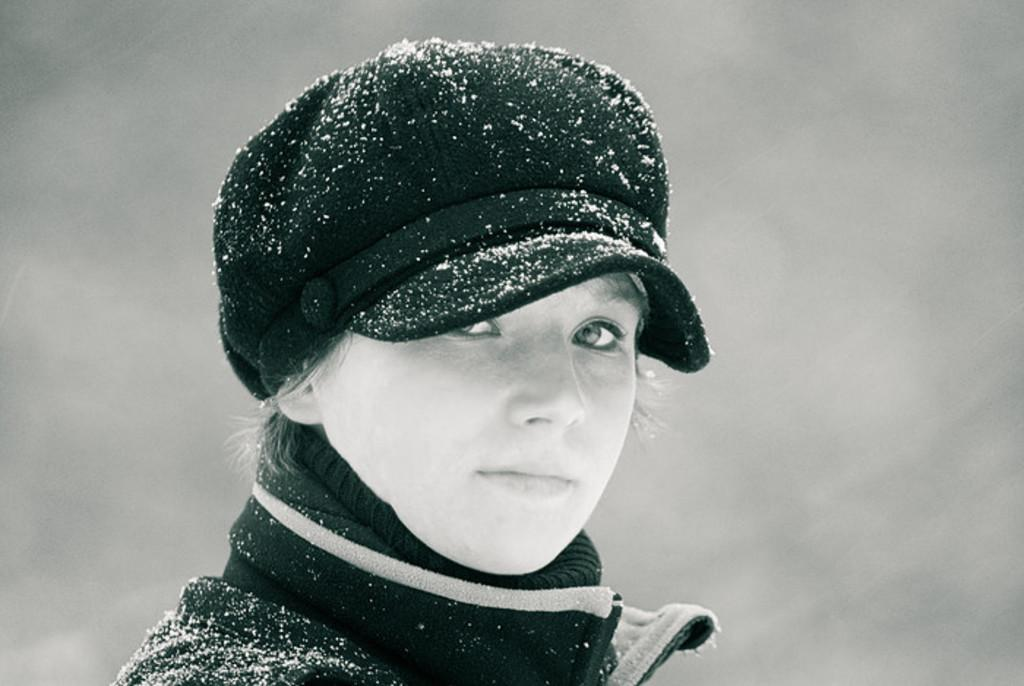Who is the main subject in the image? There is a woman in the image. What is the woman wearing on her upper body? The woman is wearing a jacket. What is the woman wearing on her head? The woman is wearing a hat. What is the weather like in the image? The presence of snow particles on the hat and jacket suggests that it is snowing. Where is the nearest plant market in the image? There is no reference to a plant market in the image, so it is not possible to determine its location. 